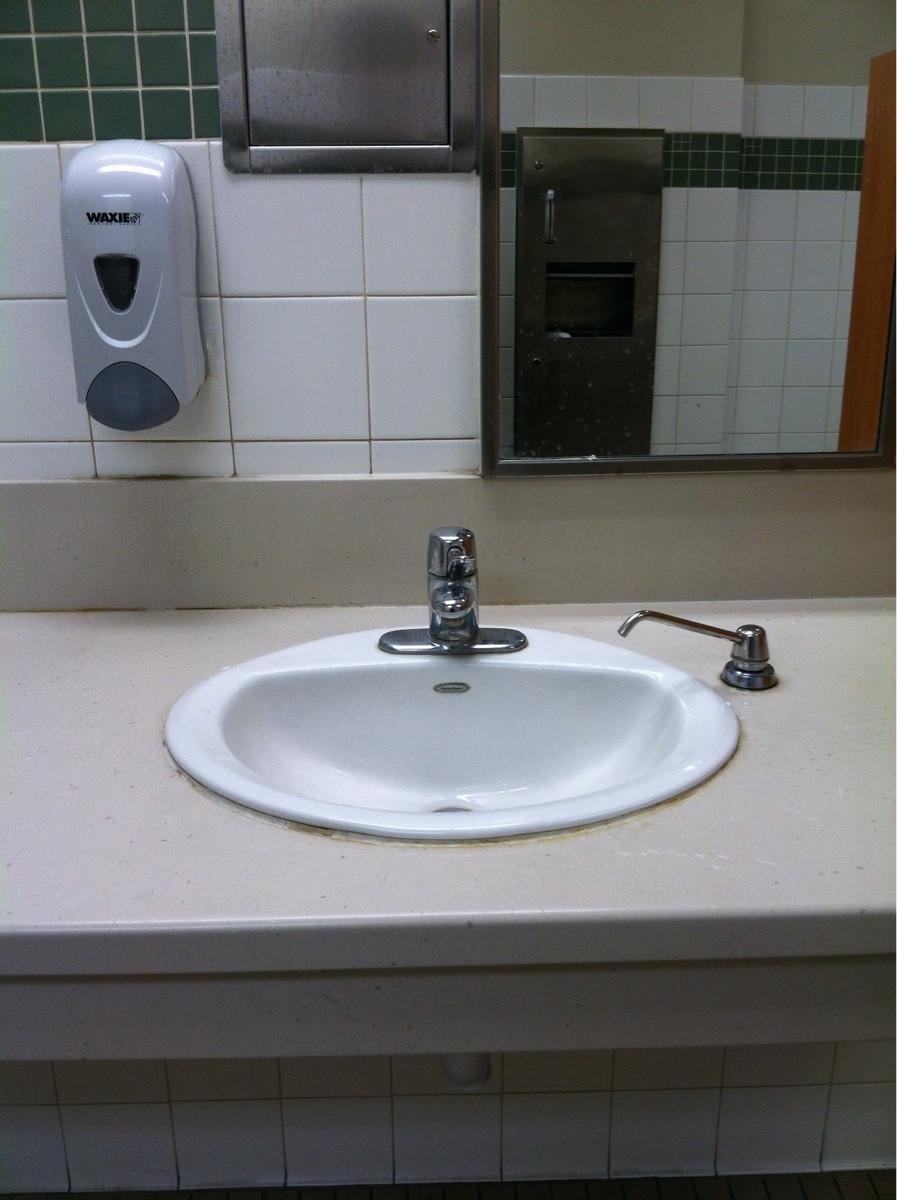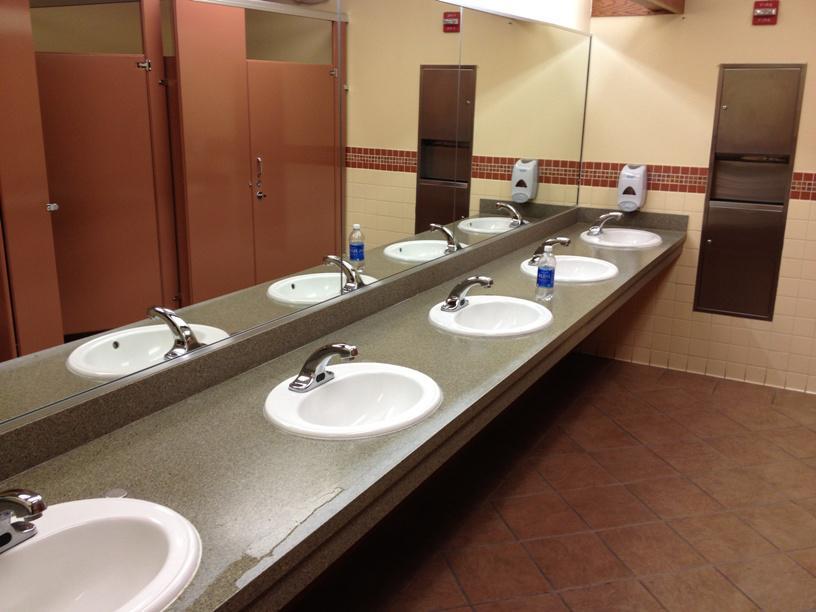The first image is the image on the left, the second image is the image on the right. For the images shown, is this caption "A person is pushing the dispenser in the image on the left." true? Answer yes or no. No. The first image is the image on the left, the second image is the image on the right. Examine the images to the left and right. Is the description "A restroom interior contains a counter with at least three identical white sinks." accurate? Answer yes or no. Yes. 